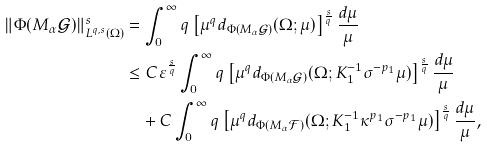<formula> <loc_0><loc_0><loc_500><loc_500>\| \Phi ( M _ { \alpha } \mathcal { G } ) \| _ { L ^ { q , s } ( \Omega ) } ^ { s } & = \int _ { 0 } ^ { \infty } q \left [ \mu ^ { q } d _ { \Phi ( M _ { \alpha } \mathcal { G } ) } ( \Omega ; \mu ) \right ] ^ { \frac { s } { q } } \frac { d \mu } { \mu } \\ & \leq C \varepsilon ^ { \frac { s } { q } } \int _ { 0 } ^ { \infty } q \left [ \mu ^ { q } d _ { \Phi ( M _ { \alpha } \mathcal { G } ) } ( \Omega ; K _ { 1 } ^ { - 1 } \sigma ^ { - p _ { 1 } } \mu ) \right ] ^ { \frac { s } { q } } \frac { d \mu } { \mu } \\ & \quad + C \int _ { 0 } ^ { \infty } q \left [ \mu ^ { q } d _ { \Phi ( M _ { \alpha } \mathcal { F } ) } ( \Omega ; K _ { 1 } ^ { - 1 } \kappa ^ { p _ { 1 } } \sigma ^ { - p _ { 1 } } \mu ) \right ] ^ { \frac { s } { q } } \frac { d \mu } { \mu } ,</formula> 